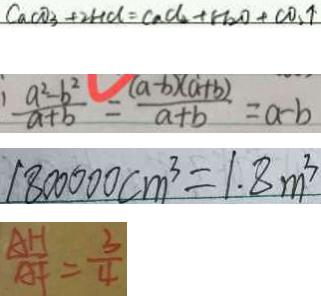Convert formula to latex. <formula><loc_0><loc_0><loc_500><loc_500>C a C O _ { 3 } + 2 H C l = c a C l _ { 2 } + H _ { 2 } O + C O _ { 2 } \uparrow 
 \frac { a ^ { 2 } - b ^ { 2 } } { a + b } = \frac { ( a - b ) ( a + b ) } { a + b } = a - b 
 1 8 0 0 0 0 0 c m ^ { 3 } = 1 . 8 m ^ { 3 } 
 \frac { A H } { A F } = \frac { 3 } { 4 }</formula> 